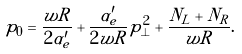Convert formula to latex. <formula><loc_0><loc_0><loc_500><loc_500>p _ { 0 } = \frac { w R } { 2 \alpha _ { e } ^ { \prime } } + \frac { \alpha _ { e } ^ { \prime } } { 2 w R } p _ { \perp } ^ { 2 } + \frac { N _ { L } + N _ { R } } { w R } .</formula> 